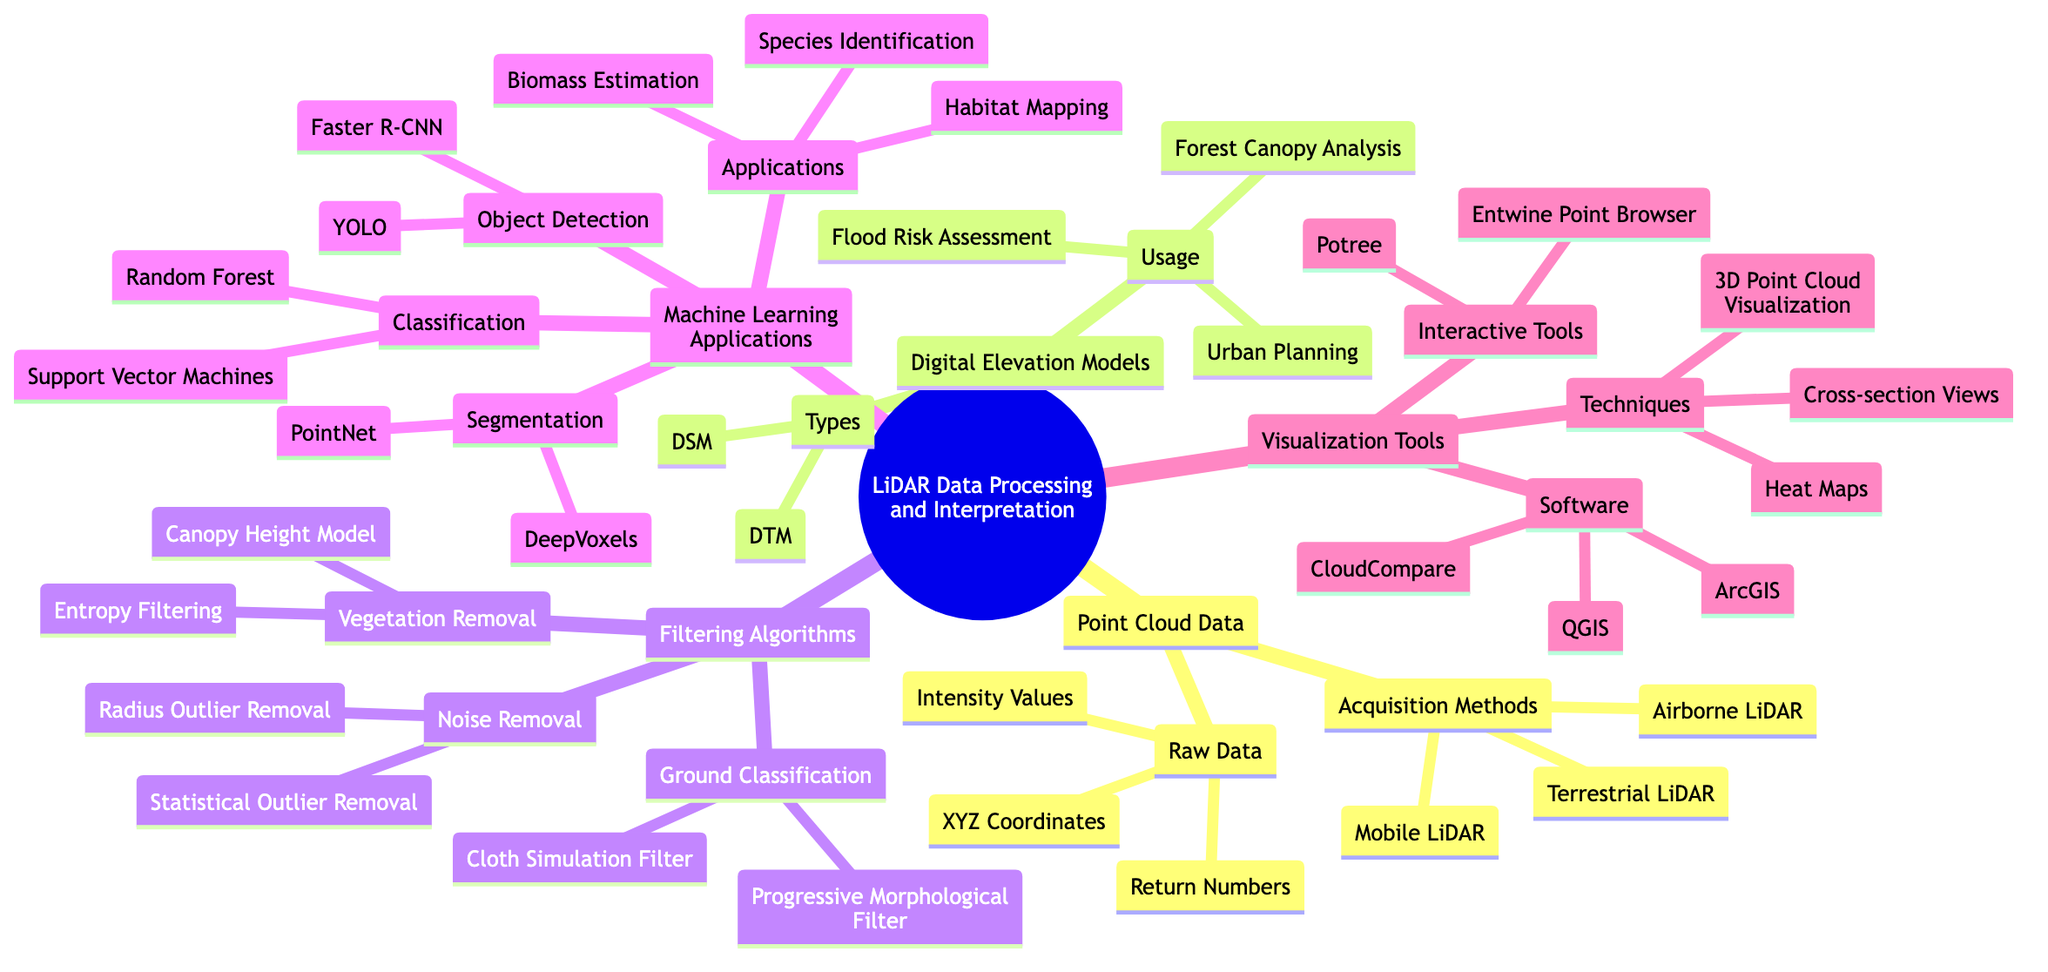What are the three acquisition methods listed under Point Cloud Data? The diagram shows three specific branches under the Point Cloud Data node, which are labeled as "Airborne LiDAR," "Terrestrial LiDAR," and "Mobile LiDAR." These are directly mentioned in the diagram.
Answer: Airborne LiDAR, Terrestrial LiDAR, Mobile LiDAR How many types of Digital Elevation Models are identified? The Digital Elevation Models section has a "Types" node that lists two specific types: "Digital Terrain Model (DTM)" and "Digital Surface Model (DSM)." Counting these items gives the answer.
Answer: 2 Which filtering algorithm is associated with noise removal? The Filtering Algorithms section contains a sub-branch labeled "Noise Removal," which explicitly mentions "Statistical Outlier Removal" and "Radius Outlier Removal." The question specifically asks which filtering algorithm pertains to noise removal, which is stated in that section.
Answer: Statistical Outlier Removal What machine learning application technique is listed under segmentation? In the Machine Learning Applications section, there is a sub-category named "Segmentation" which directly lists "PointNet" and "DeepVoxels" as its associated techniques. To answer the question, we refer to this part of the diagram.
Answer: PointNet What are two visualization techniques mentioned in the diagram? Within the Visualization Tools section, there is a node labeled "Techniques" that lists "3D Point Cloud Visualization," "Heat Maps," and "Cross-section Views." The question asks for two techniques, so we can simply pick any two from this list.
Answer: 3D Point Cloud Visualization, Heat Maps How is the relationship between "Machine Learning Applications" and "Applications" indicated? The diagram displays a hierarchical structure where "Machine Learning Applications" is a higher-level node that branches into several subcategories, with "Applications" being one of them. It suggests that "Applications" are various usages stemming from machine learning techniques. Therefore, the relationship is hierarchical and based on application areas of machine learning in the context of LiDAR.
Answer: Hierarchical What is the purpose of a Digital Terrain Model? The Usage node under Digital Elevation Models lists various purposes including "Forest Canopy Analysis," "Flood Risk Assessment," and "Urban Planning." The question is about the purpose, which implies that these usages relate directly to what Digital Elevation Models, specifically DTM, are used for.
Answer: Forest Canopy Analysis Which interactive tool is included in the Visualization Tools section? The Visualization Tools section has an "Interactive Tools" sub-node that includes "Potree" and "Entwine Point Browser." The question is straightforward regarding the mention of interactive tools.
Answer: Potree How many aspects of Filtering Algorithms are listed in the diagram? The Filtering Algorithms branch shows that there are three main aspects: "Noise Removal," "Ground Classification," and "Vegetation Removal." To find the answer, we count these branches under the Filtering Algorithms node.
Answer: 3 